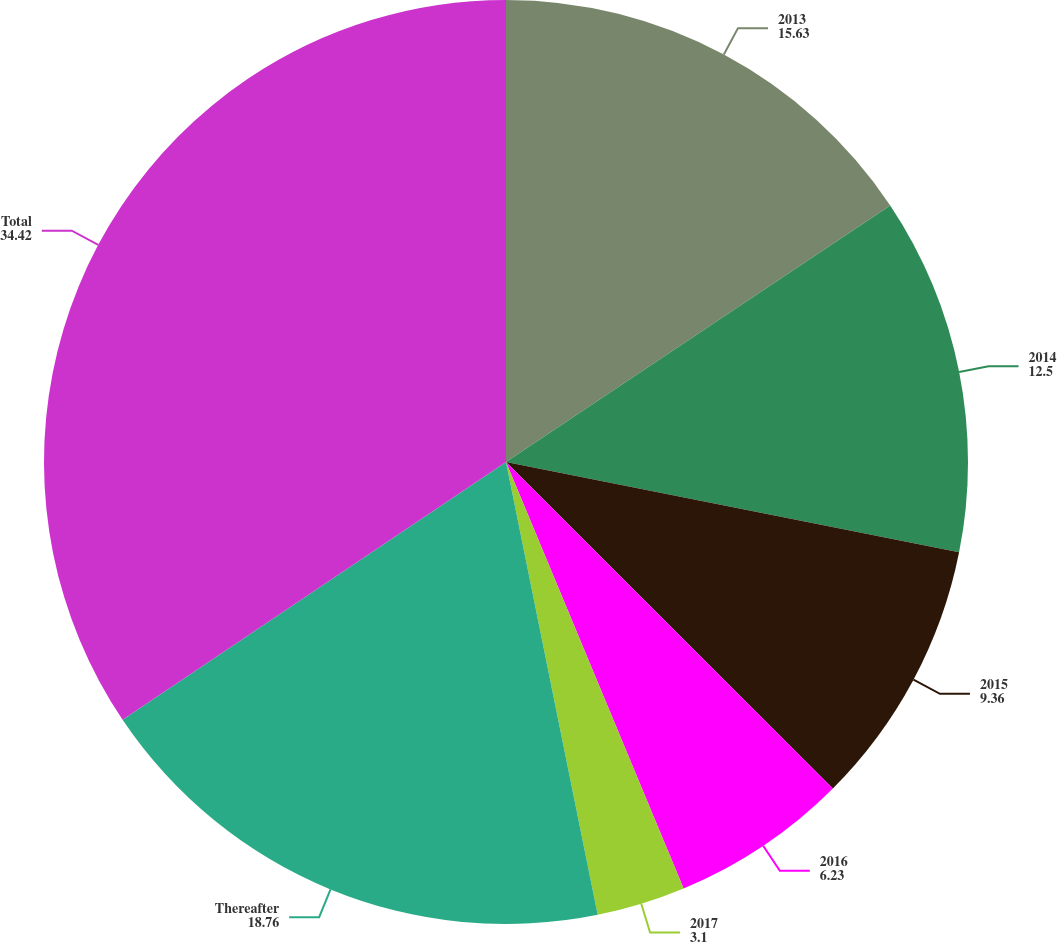<chart> <loc_0><loc_0><loc_500><loc_500><pie_chart><fcel>2013<fcel>2014<fcel>2015<fcel>2016<fcel>2017<fcel>Thereafter<fcel>Total<nl><fcel>15.63%<fcel>12.5%<fcel>9.36%<fcel>6.23%<fcel>3.1%<fcel>18.76%<fcel>34.42%<nl></chart> 